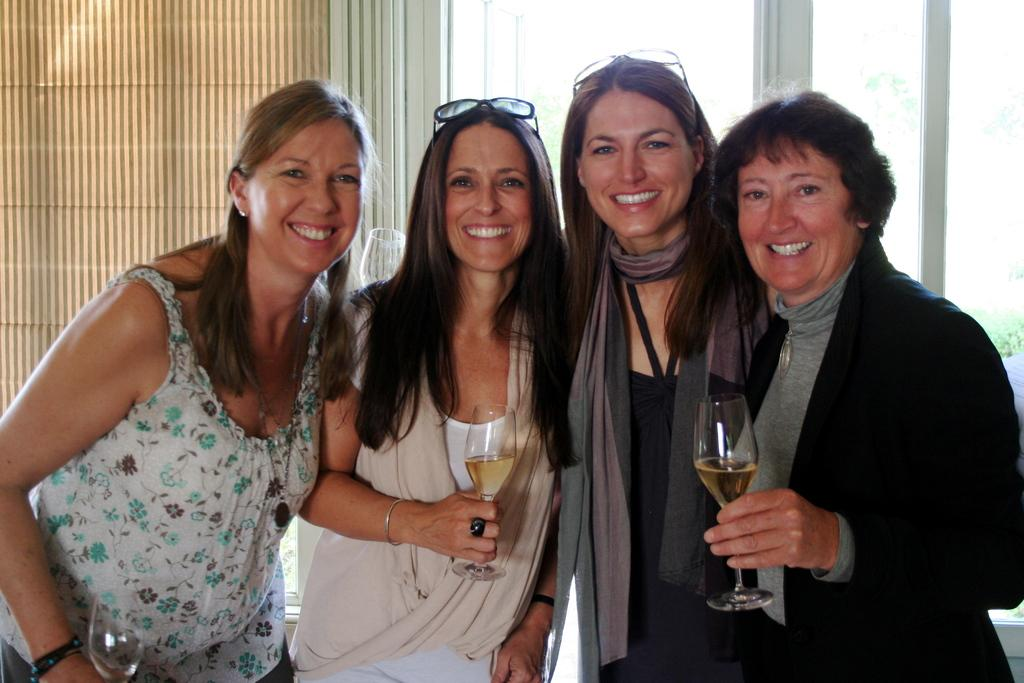How many women are present in the image? There are four women in the image. What are the women doing in the image? The women are standing and smiling. What are the women holding in their hands? The women are holding glasses in their hands. What type of shade can be seen in the image? There is no shade present in the image. Are the women standing near any trees in the image? There is no mention of trees in the image, so it cannot be determined if the women are standing near any. 